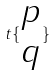Convert formula to latex. <formula><loc_0><loc_0><loc_500><loc_500>t \{ \begin{matrix} p \\ q \end{matrix} \}</formula> 